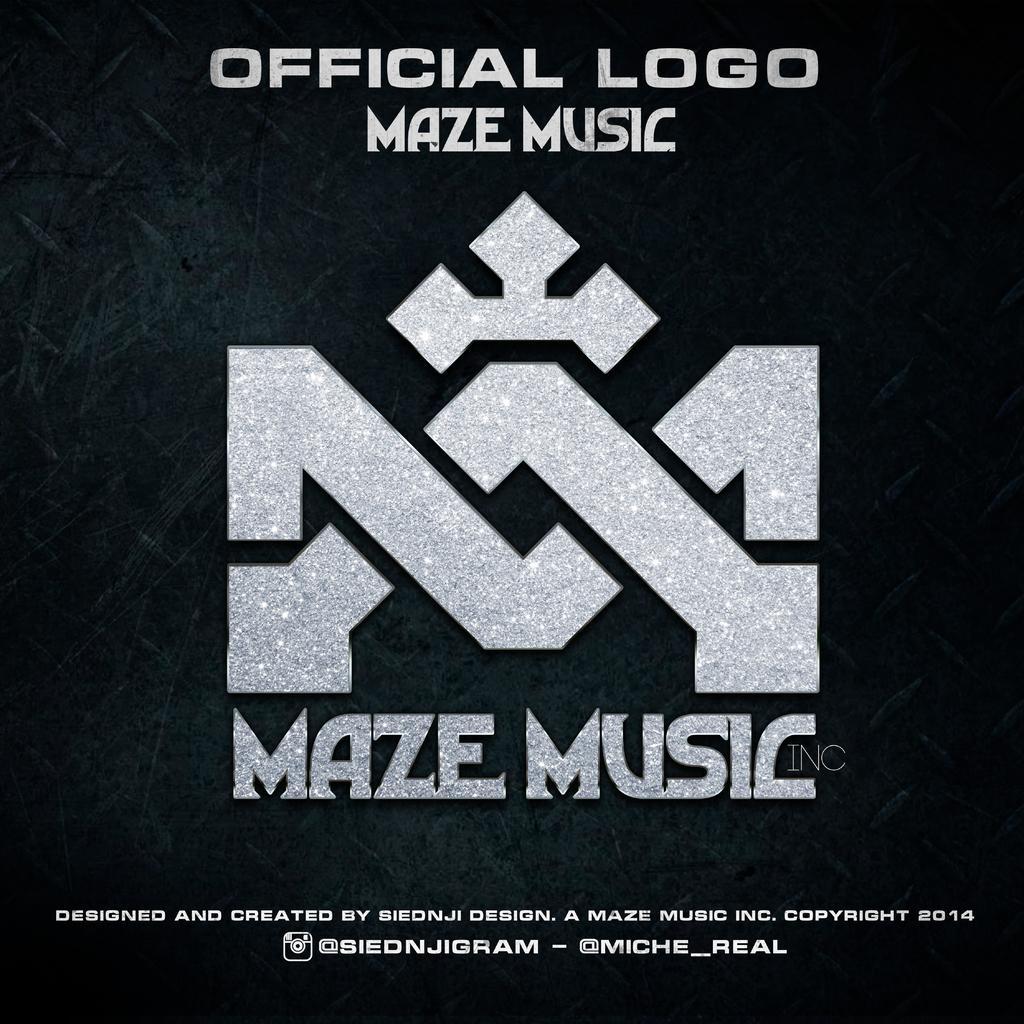Describe this image in one or two sentences. This picture consists of text and logo ,background is black. 